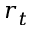<formula> <loc_0><loc_0><loc_500><loc_500>r _ { t }</formula> 